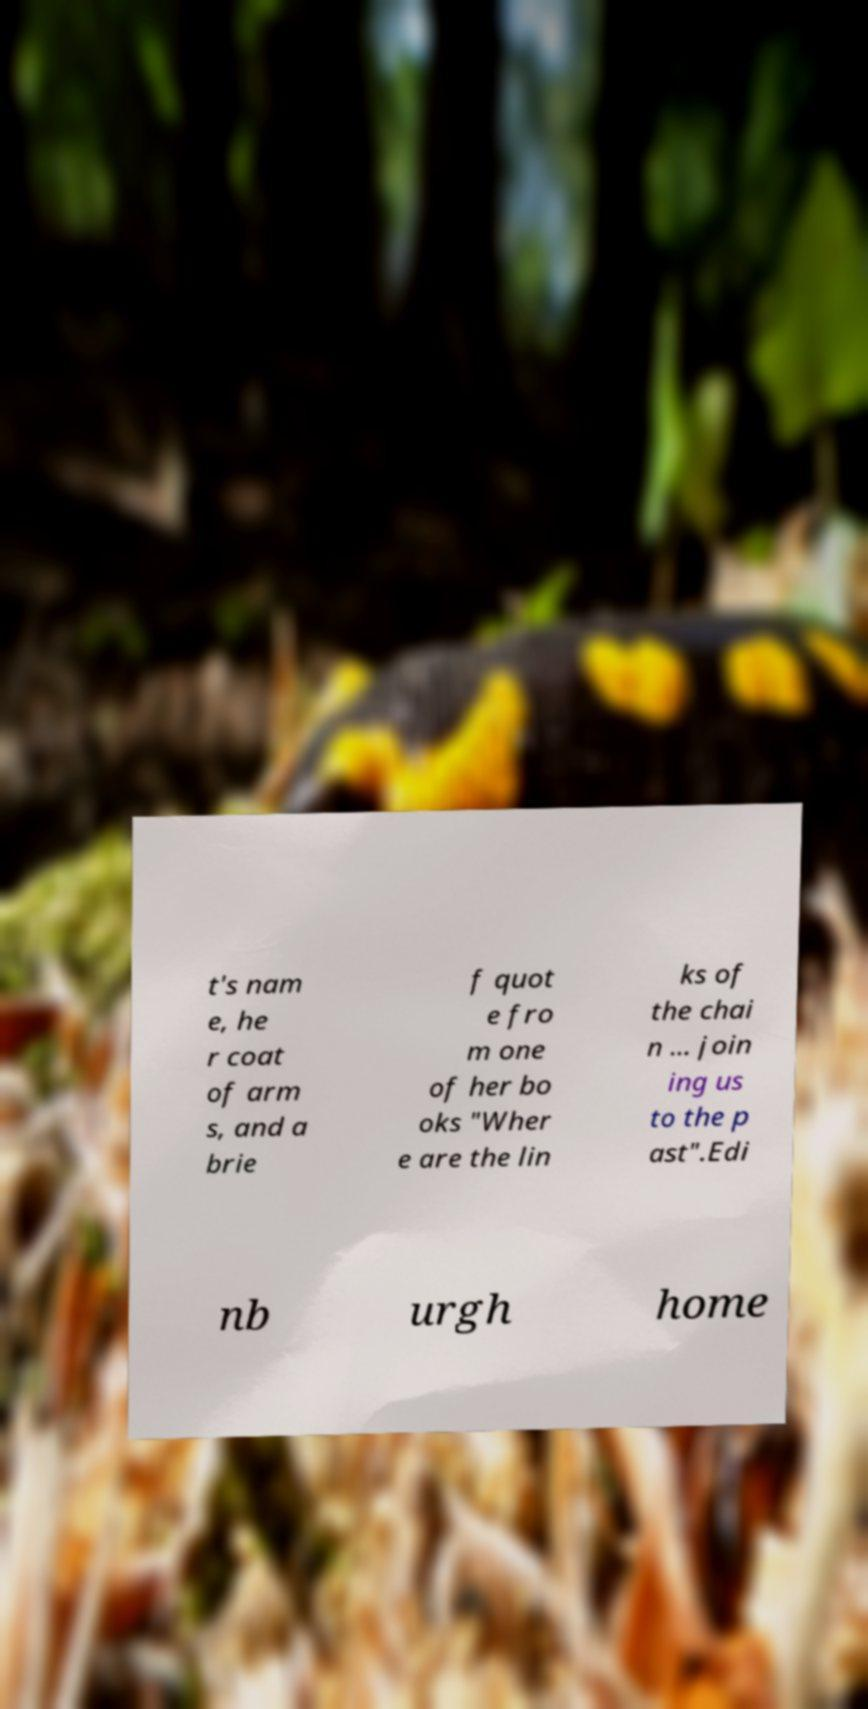Could you extract and type out the text from this image? t's nam e, he r coat of arm s, and a brie f quot e fro m one of her bo oks "Wher e are the lin ks of the chai n ... join ing us to the p ast".Edi nb urgh home 